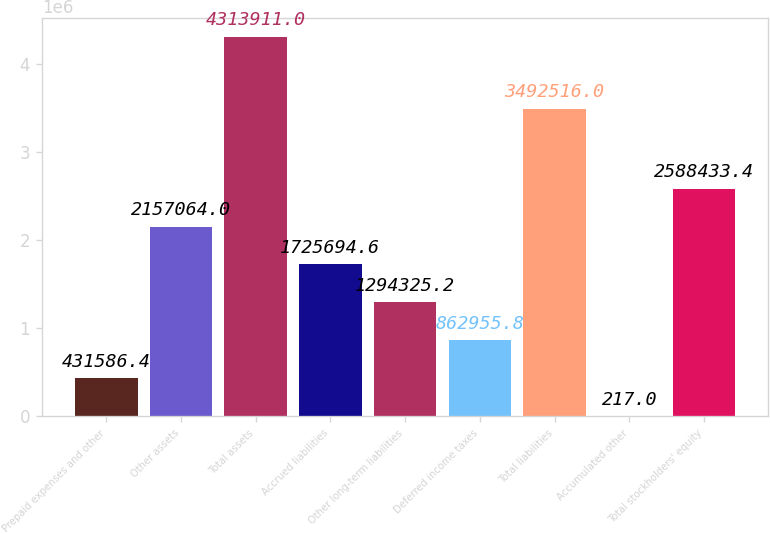<chart> <loc_0><loc_0><loc_500><loc_500><bar_chart><fcel>Prepaid expenses and other<fcel>Other assets<fcel>Total assets<fcel>Accrued liabilities<fcel>Other long-term liabilities<fcel>Deferred income taxes<fcel>Total liabilities<fcel>Accumulated other<fcel>Total stockholders' equity<nl><fcel>431586<fcel>2.15706e+06<fcel>4.31391e+06<fcel>1.72569e+06<fcel>1.29433e+06<fcel>862956<fcel>3.49252e+06<fcel>217<fcel>2.58843e+06<nl></chart> 